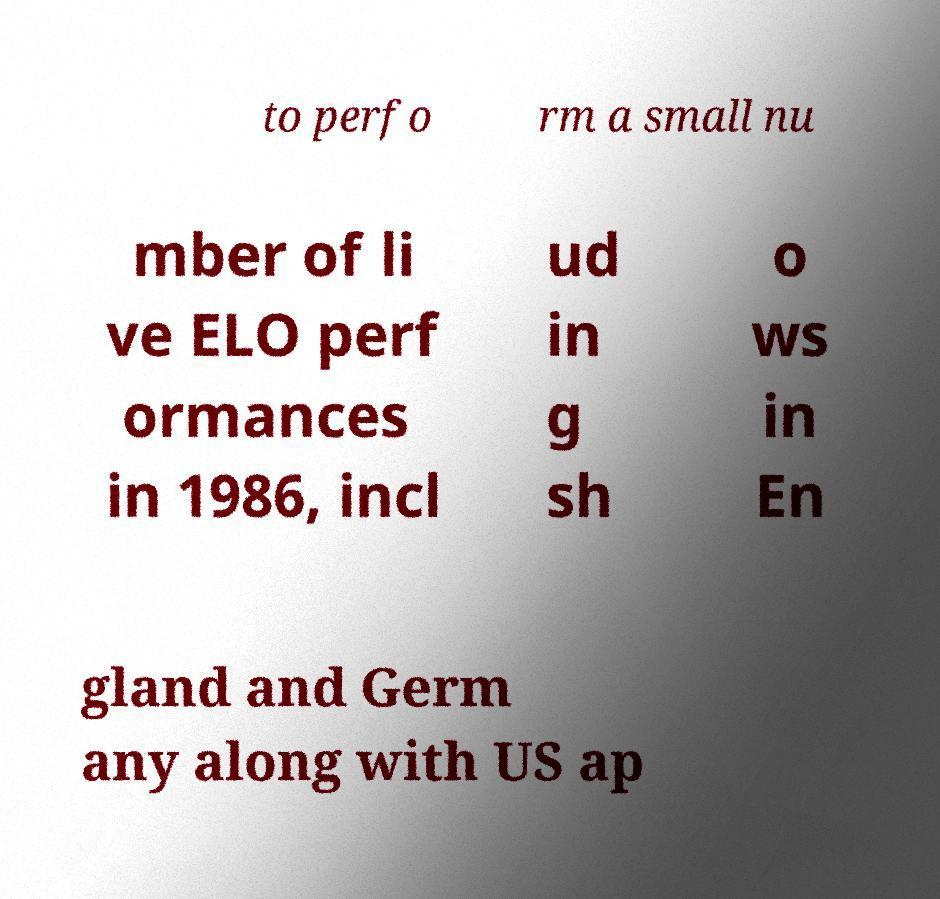Can you accurately transcribe the text from the provided image for me? to perfo rm a small nu mber of li ve ELO perf ormances in 1986, incl ud in g sh o ws in En gland and Germ any along with US ap 